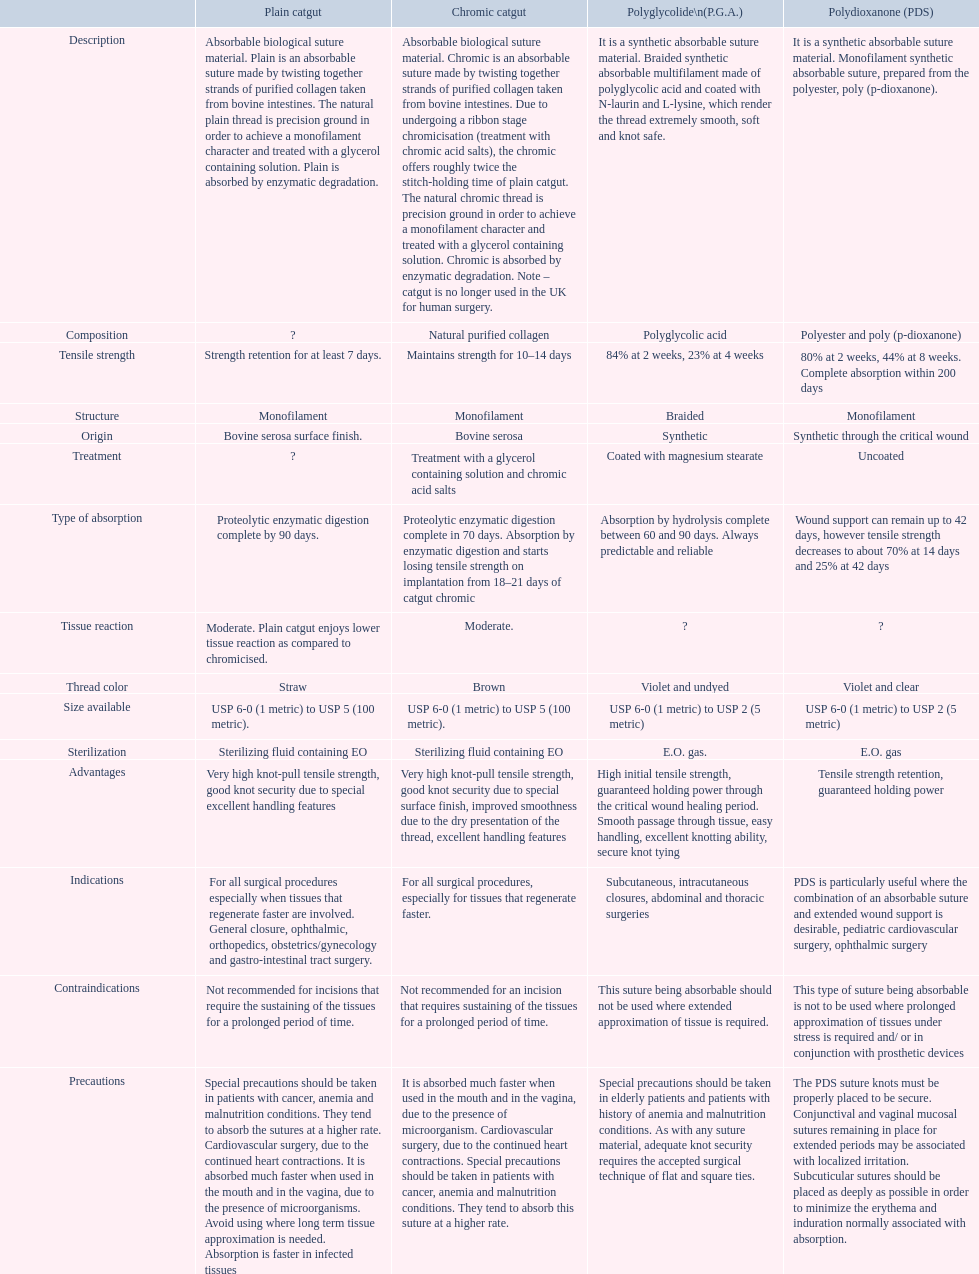How many days is the strength of chronic catgut sustained? Maintains strength for 10–14 days. What is basic catgut? Absorbable biological suture material. Plain is an absorbable suture made by twisting together strands of purified collagen taken from bovine intestines. The natural plain thread is precision ground in order to achieve a monofilament character and treated with a glycerol containing solution. Plain is absorbed by enzymatic degradation. How many days is the strength of catgut maintained? Strength retention for at least 7 days. 